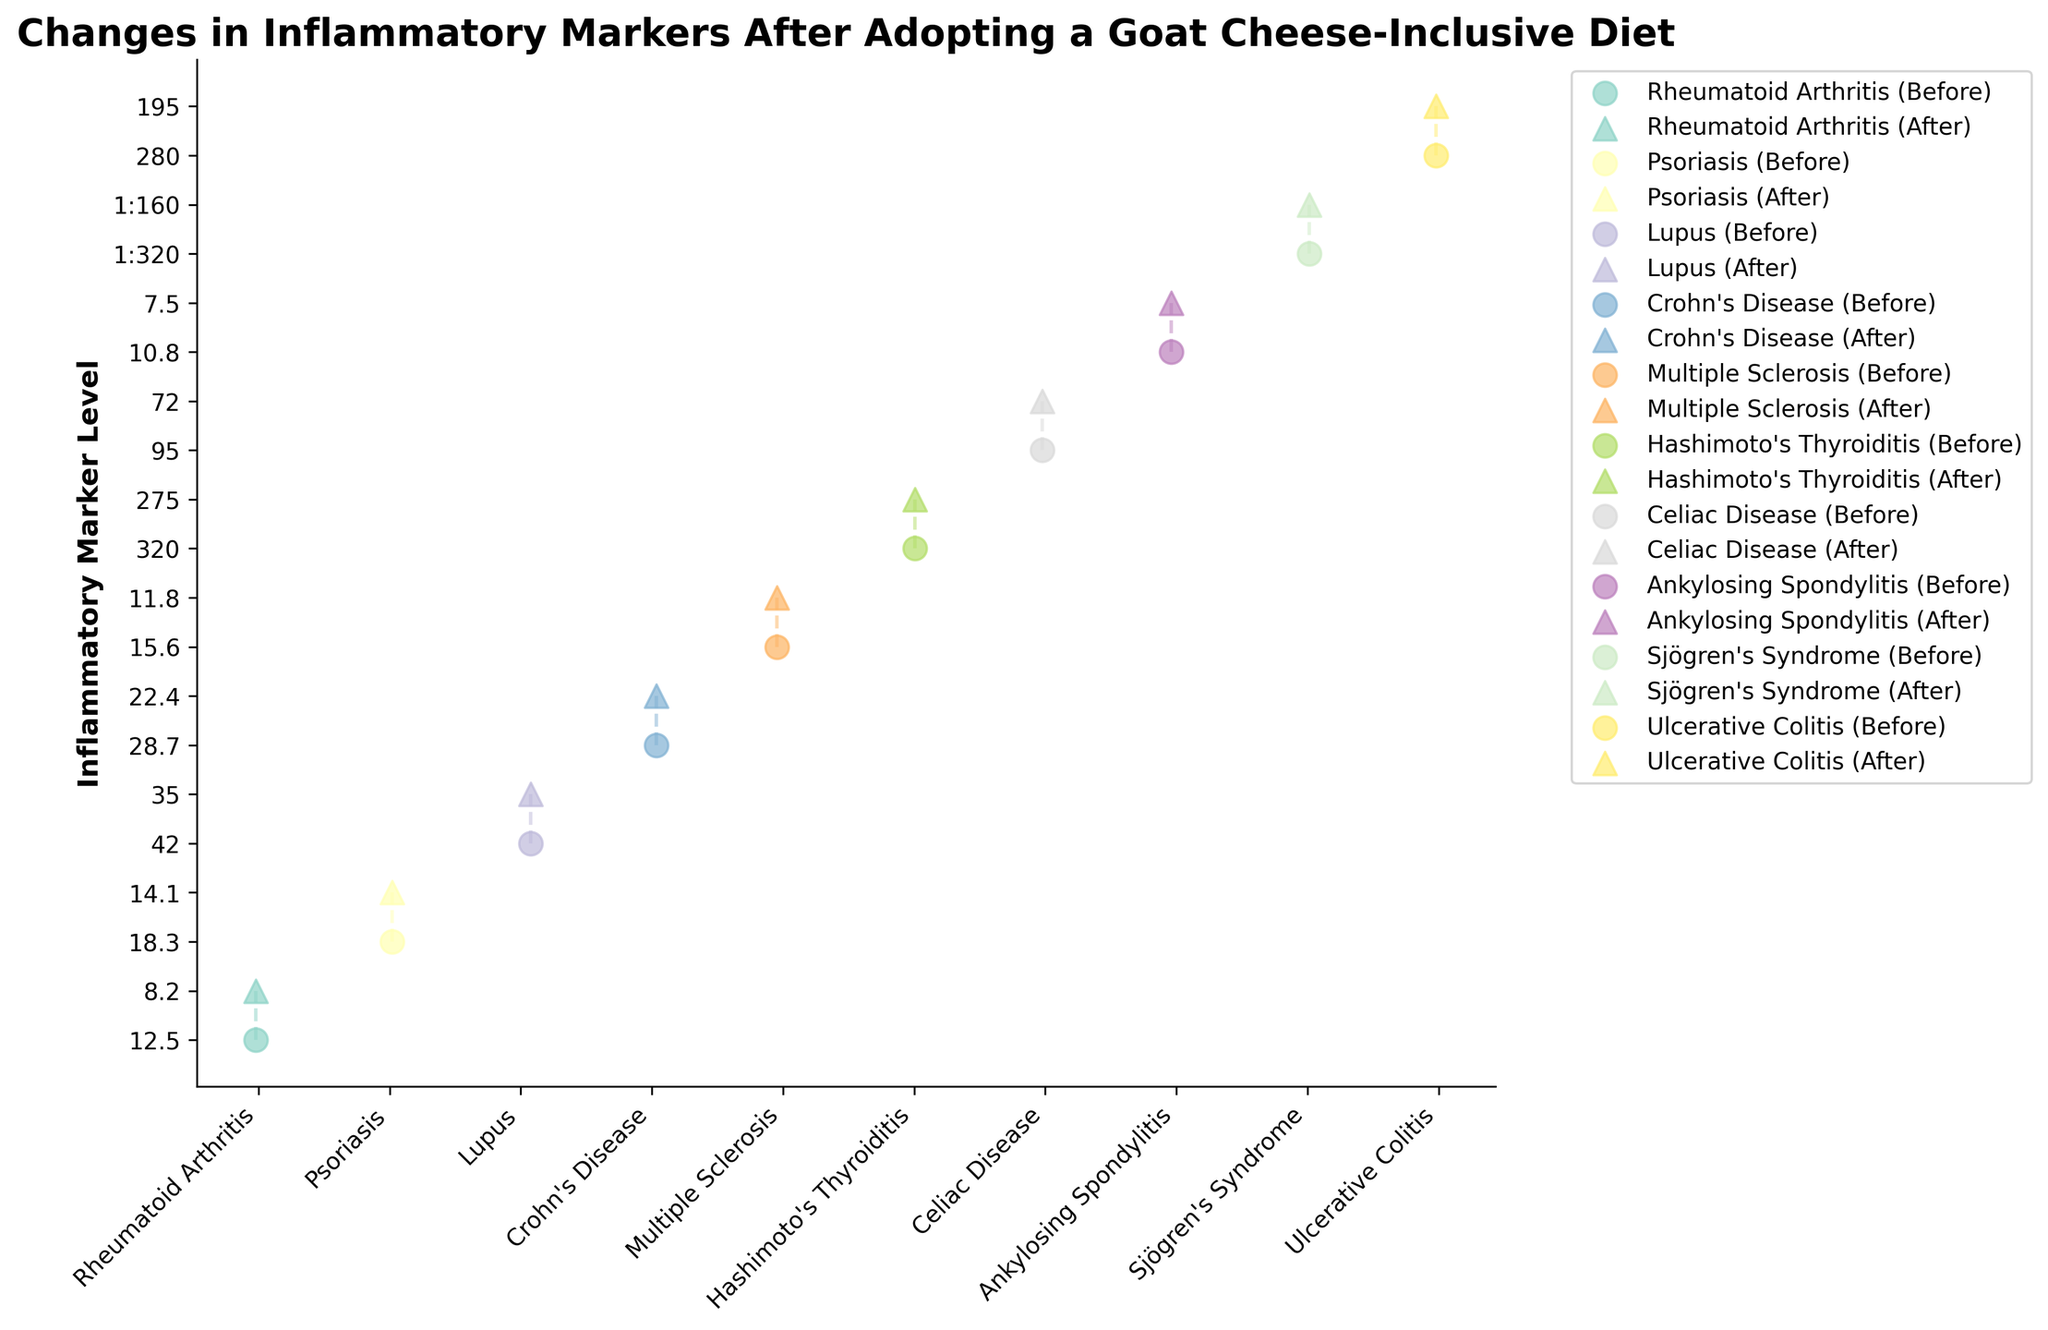What is the title of the figure? The title of the figure is usually located at the top center. In this case, it reads 'Changes in Inflammatory Markers After Adopting a Goat Cheese-Inclusive Diet'.
Answer: Changes in Inflammatory Markers After Adopting a Goat Cheese-Inclusive Diet Which condition has a visibly noticeable reduction in inflammatory markers after the diet change? By inspecting the figure, identify the condition with a substantial drop in the marker level between 'Before' and 'After' points. For example, 'Celiac Disease' shows a noticeable large drop.
Answer: Celiac Disease How many different autoimmune conditions are represented in the figure? The x-axis labels represent the number of different conditions. By counting these labels, we find there are 10 different conditions.
Answer: 10 For which condition does the figure display the most significant reduction in Marker values after the diet change? To find this, look for the longest vertical drop between pairs of 'Before' and 'After' points connected by dashed lines. 'Ulcerative Colitis' shows a significant drop from 280 to 195.
Answer: Ulcerative Colitis What are the symbols used to represent 'Before' and 'After' the diet change in the figure? From the legend, it can be seen that circles (o) represent 'Before' and triangles (^) represent 'After'.
Answer: Circles for 'Before' and triangles for 'After' Which autoimmune condition has the smallest absolute change in inflammatory marker levels? Calculate the absolute change by subtracting 'After' values from 'Before' values for each condition. The smallest change can be observed for 'Psoriasis' (18.3 - 14.1 = 4.2).
Answer: Psoriasis Which condition shows the highest initial inflammatory marker level before the dietary change? Check the 'Before' values across all conditions. 'Celiac Disease' has the highest initial marker level with a value of 95.
Answer: Celiac Disease In which condition are the 'Before' and 'After' marker levels most closely spaced? The most closely spaced points, indicating the smallest change, are for 'Psoriasis' (18.3 to 14.1).
Answer: Psoriasis Do any conditions show no improvement (no reduction) after the diet change? To determine this, check if any of the 'After' markers are equal to or higher than the 'Before' markers. All conditions do show some reduction, so none show no improvement.
Answer: No 